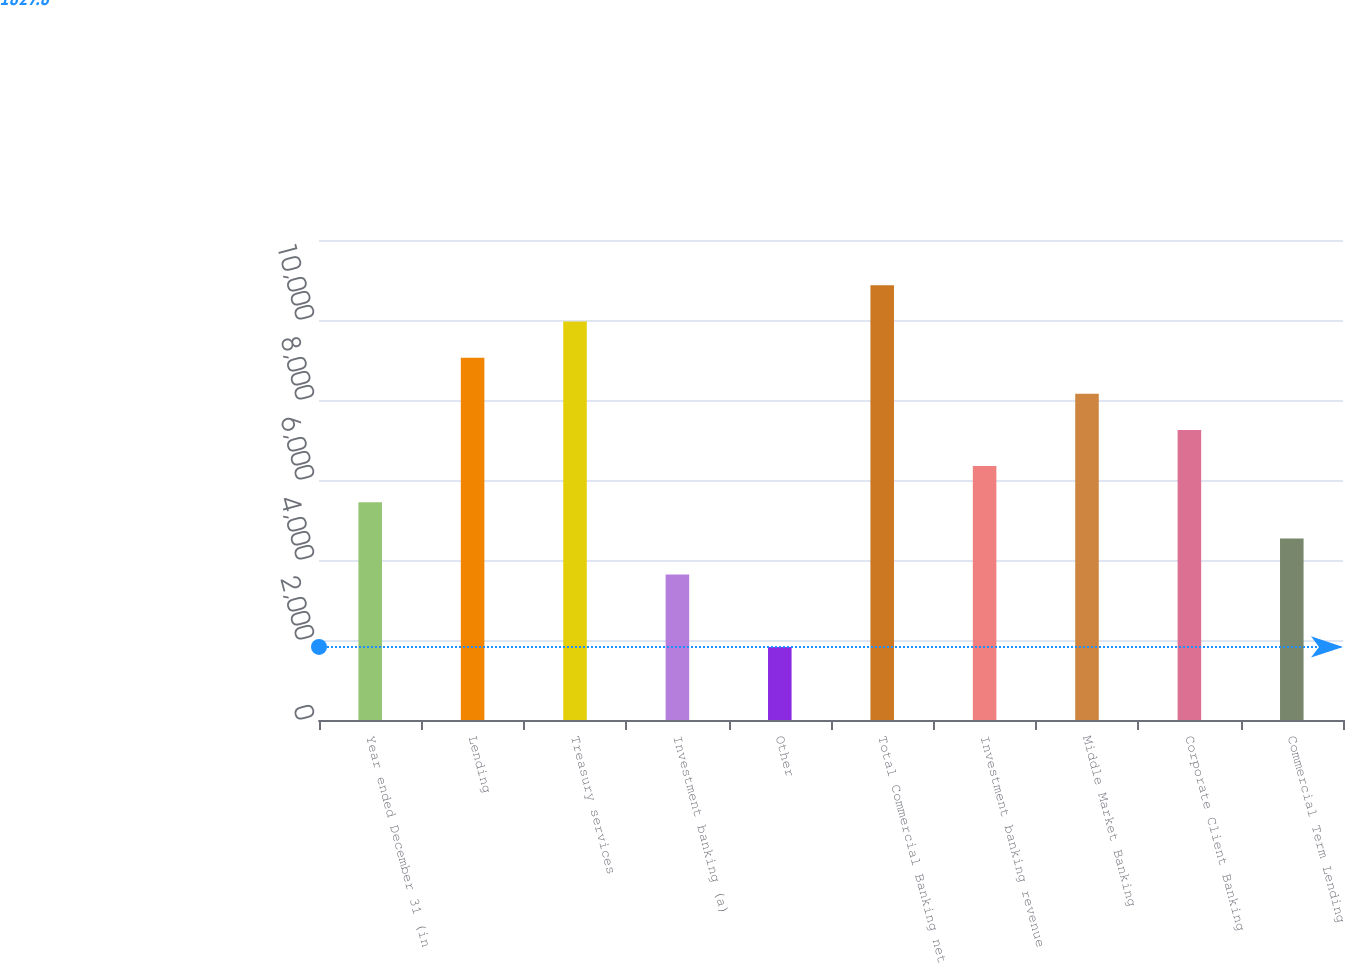<chart> <loc_0><loc_0><loc_500><loc_500><bar_chart><fcel>Year ended December 31 (in<fcel>Lending<fcel>Treasury services<fcel>Investment banking (a)<fcel>Other<fcel>Total Commercial Banking net<fcel>Investment banking revenue<fcel>Middle Market Banking<fcel>Corporate Client Banking<fcel>Commercial Term Lending<nl><fcel>5443.4<fcel>9059<fcel>9962.9<fcel>3635.6<fcel>1827.8<fcel>10866.8<fcel>6347.3<fcel>8155.1<fcel>7251.2<fcel>4539.5<nl></chart> 